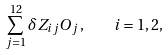<formula> <loc_0><loc_0><loc_500><loc_500>\sum _ { j = 1 } ^ { 1 2 } \delta Z _ { i j } O _ { j } \, , \quad i = 1 , 2 ,</formula> 